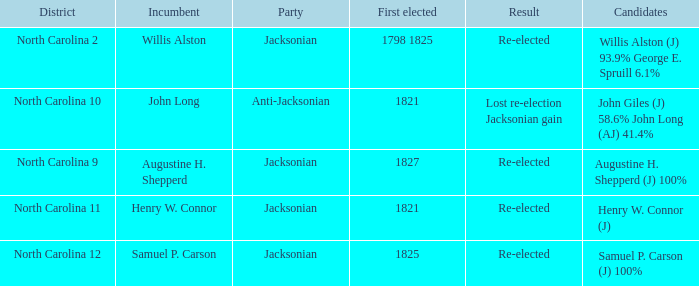Name the result for willis alston Re-elected. 